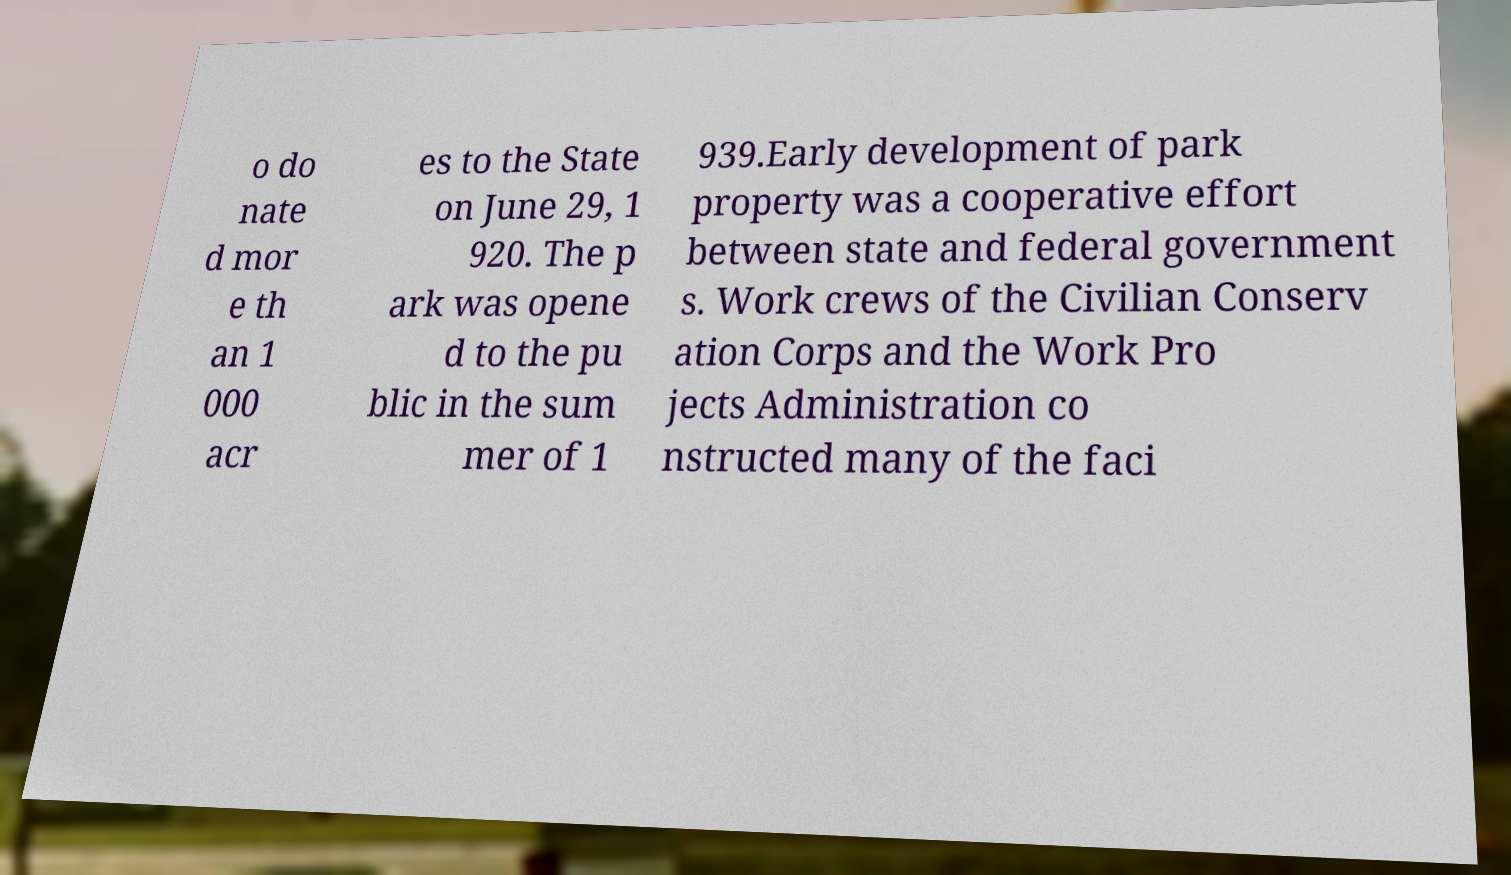There's text embedded in this image that I need extracted. Can you transcribe it verbatim? o do nate d mor e th an 1 000 acr es to the State on June 29, 1 920. The p ark was opene d to the pu blic in the sum mer of 1 939.Early development of park property was a cooperative effort between state and federal government s. Work crews of the Civilian Conserv ation Corps and the Work Pro jects Administration co nstructed many of the faci 